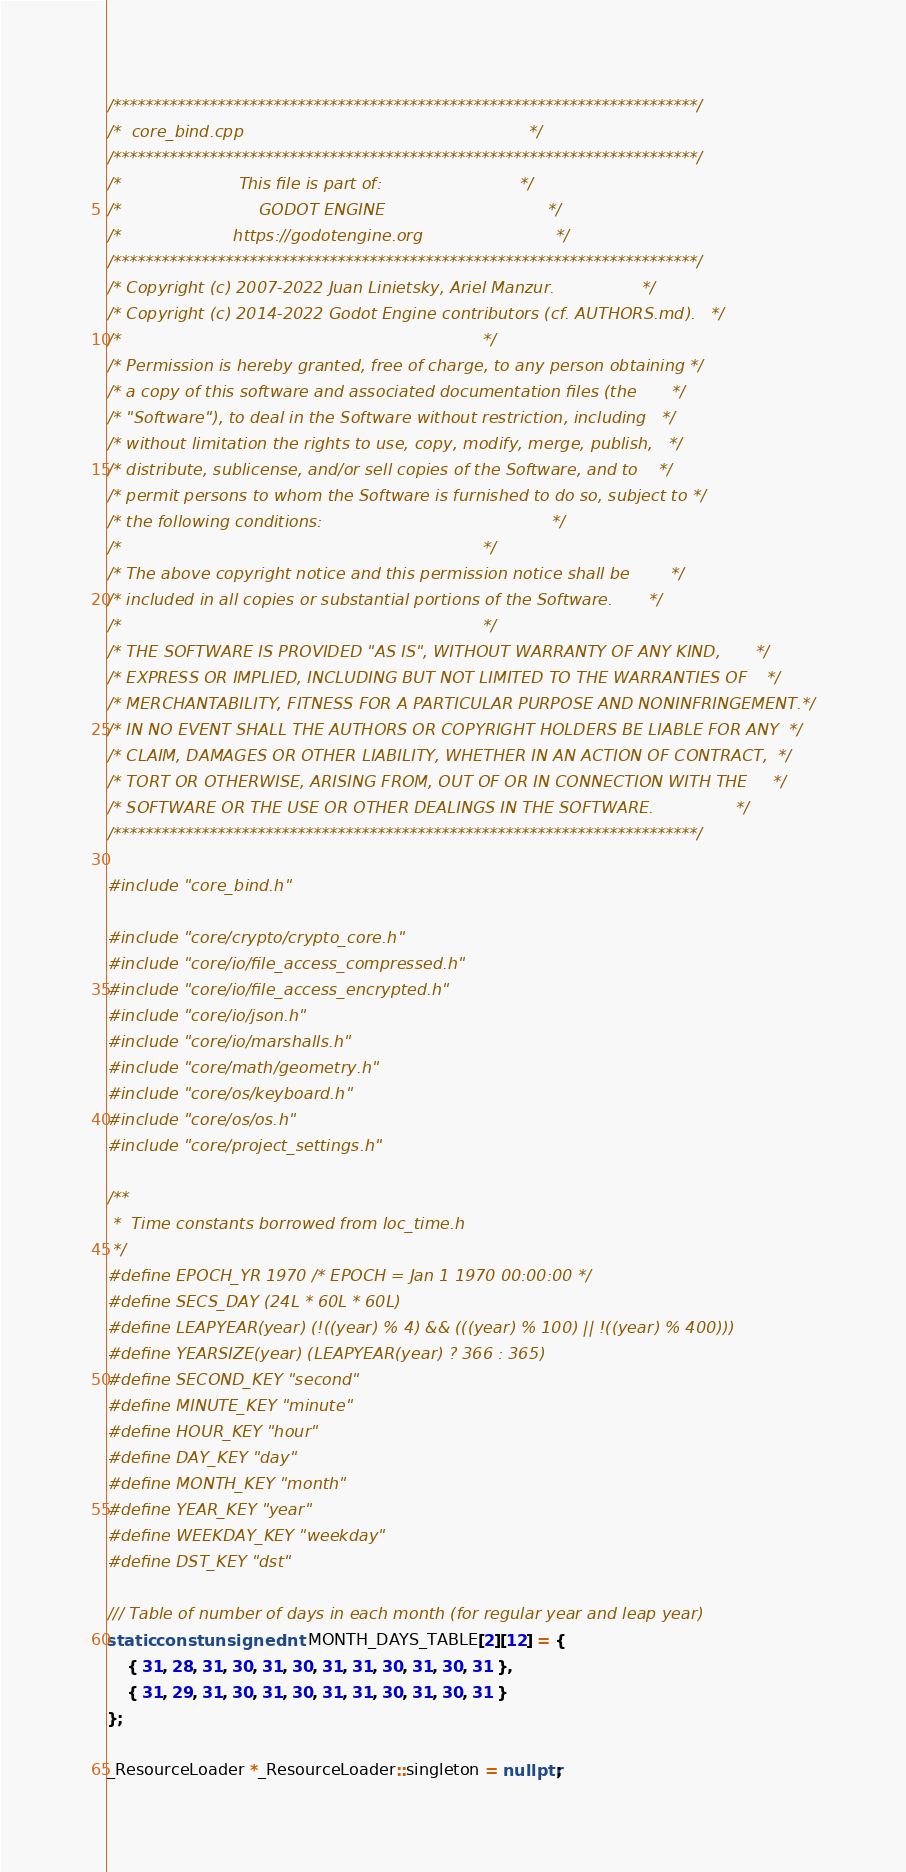Convert code to text. <code><loc_0><loc_0><loc_500><loc_500><_C++_>/*************************************************************************/
/*  core_bind.cpp                                                        */
/*************************************************************************/
/*                       This file is part of:                           */
/*                           GODOT ENGINE                                */
/*                      https://godotengine.org                          */
/*************************************************************************/
/* Copyright (c) 2007-2022 Juan Linietsky, Ariel Manzur.                 */
/* Copyright (c) 2014-2022 Godot Engine contributors (cf. AUTHORS.md).   */
/*                                                                       */
/* Permission is hereby granted, free of charge, to any person obtaining */
/* a copy of this software and associated documentation files (the       */
/* "Software"), to deal in the Software without restriction, including   */
/* without limitation the rights to use, copy, modify, merge, publish,   */
/* distribute, sublicense, and/or sell copies of the Software, and to    */
/* permit persons to whom the Software is furnished to do so, subject to */
/* the following conditions:                                             */
/*                                                                       */
/* The above copyright notice and this permission notice shall be        */
/* included in all copies or substantial portions of the Software.       */
/*                                                                       */
/* THE SOFTWARE IS PROVIDED "AS IS", WITHOUT WARRANTY OF ANY KIND,       */
/* EXPRESS OR IMPLIED, INCLUDING BUT NOT LIMITED TO THE WARRANTIES OF    */
/* MERCHANTABILITY, FITNESS FOR A PARTICULAR PURPOSE AND NONINFRINGEMENT.*/
/* IN NO EVENT SHALL THE AUTHORS OR COPYRIGHT HOLDERS BE LIABLE FOR ANY  */
/* CLAIM, DAMAGES OR OTHER LIABILITY, WHETHER IN AN ACTION OF CONTRACT,  */
/* TORT OR OTHERWISE, ARISING FROM, OUT OF OR IN CONNECTION WITH THE     */
/* SOFTWARE OR THE USE OR OTHER DEALINGS IN THE SOFTWARE.                */
/*************************************************************************/

#include "core_bind.h"

#include "core/crypto/crypto_core.h"
#include "core/io/file_access_compressed.h"
#include "core/io/file_access_encrypted.h"
#include "core/io/json.h"
#include "core/io/marshalls.h"
#include "core/math/geometry.h"
#include "core/os/keyboard.h"
#include "core/os/os.h"
#include "core/project_settings.h"

/**
 *  Time constants borrowed from loc_time.h
 */
#define EPOCH_YR 1970 /* EPOCH = Jan 1 1970 00:00:00 */
#define SECS_DAY (24L * 60L * 60L)
#define LEAPYEAR(year) (!((year) % 4) && (((year) % 100) || !((year) % 400)))
#define YEARSIZE(year) (LEAPYEAR(year) ? 366 : 365)
#define SECOND_KEY "second"
#define MINUTE_KEY "minute"
#define HOUR_KEY "hour"
#define DAY_KEY "day"
#define MONTH_KEY "month"
#define YEAR_KEY "year"
#define WEEKDAY_KEY "weekday"
#define DST_KEY "dst"

/// Table of number of days in each month (for regular year and leap year)
static const unsigned int MONTH_DAYS_TABLE[2][12] = {
	{ 31, 28, 31, 30, 31, 30, 31, 31, 30, 31, 30, 31 },
	{ 31, 29, 31, 30, 31, 30, 31, 31, 30, 31, 30, 31 }
};

_ResourceLoader *_ResourceLoader::singleton = nullptr;
</code> 